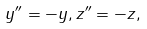Convert formula to latex. <formula><loc_0><loc_0><loc_500><loc_500>y ^ { \prime \prime } = - y , z ^ { \prime \prime } = - z ,</formula> 